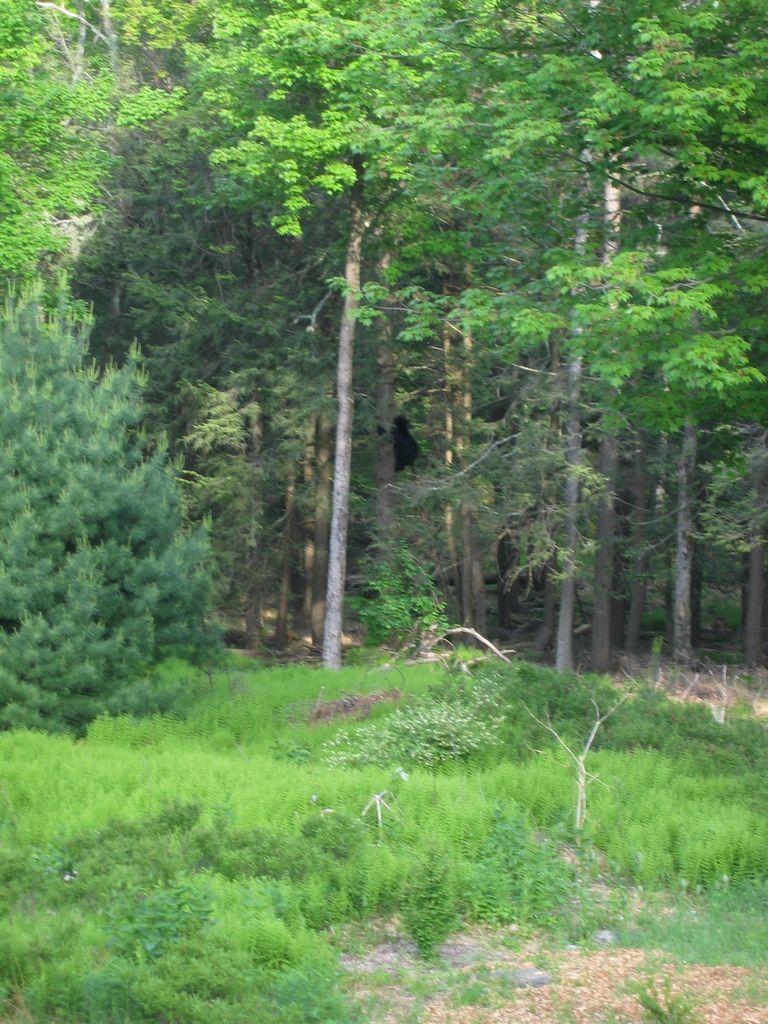Can you describe this image briefly? In this image there is grass, plants, trees. 